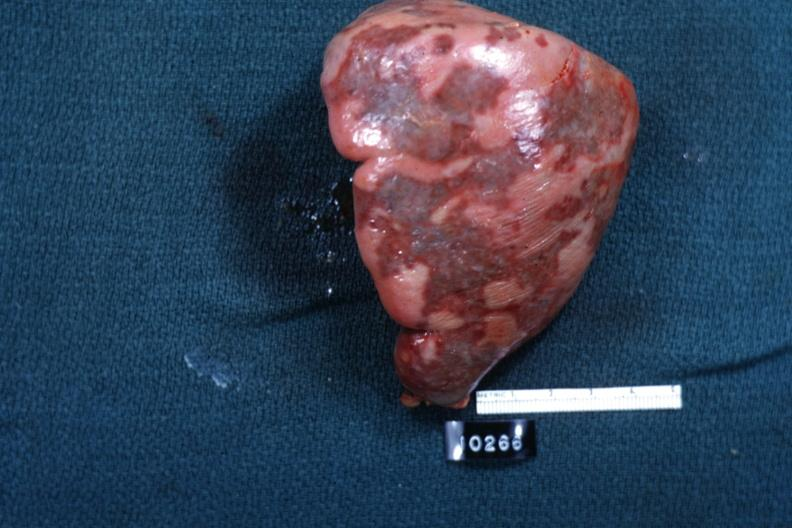what is present?
Answer the question using a single word or phrase. Hematologic 